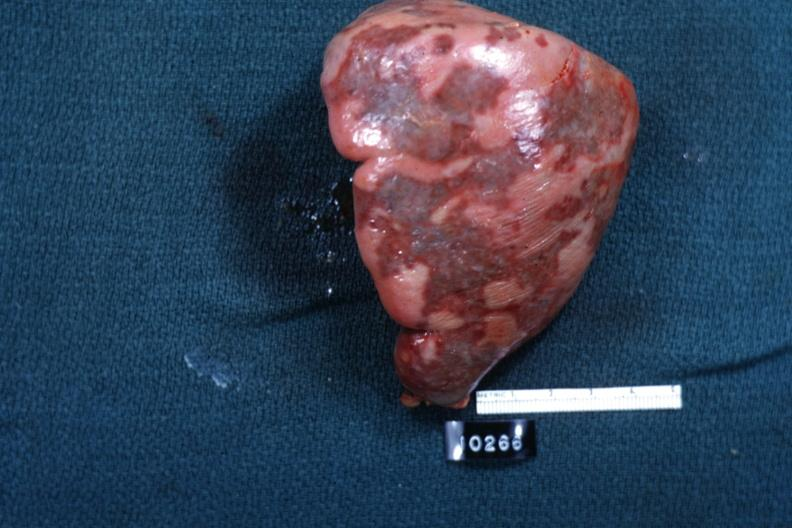what is present?
Answer the question using a single word or phrase. Hematologic 